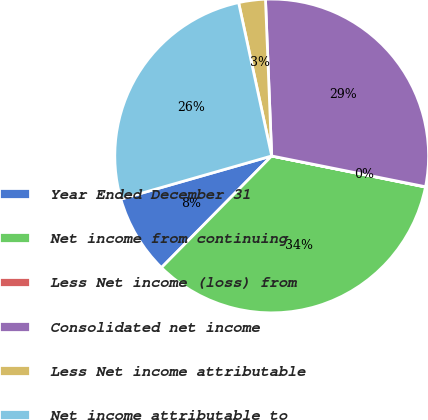<chart> <loc_0><loc_0><loc_500><loc_500><pie_chart><fcel>Year Ended December 31<fcel>Net income from continuing<fcel>Less Net income (loss) from<fcel>Consolidated net income<fcel>Less Net income attributable<fcel>Net income attributable to<nl><fcel>8.17%<fcel>34.22%<fcel>0.03%<fcel>28.77%<fcel>2.75%<fcel>26.05%<nl></chart> 